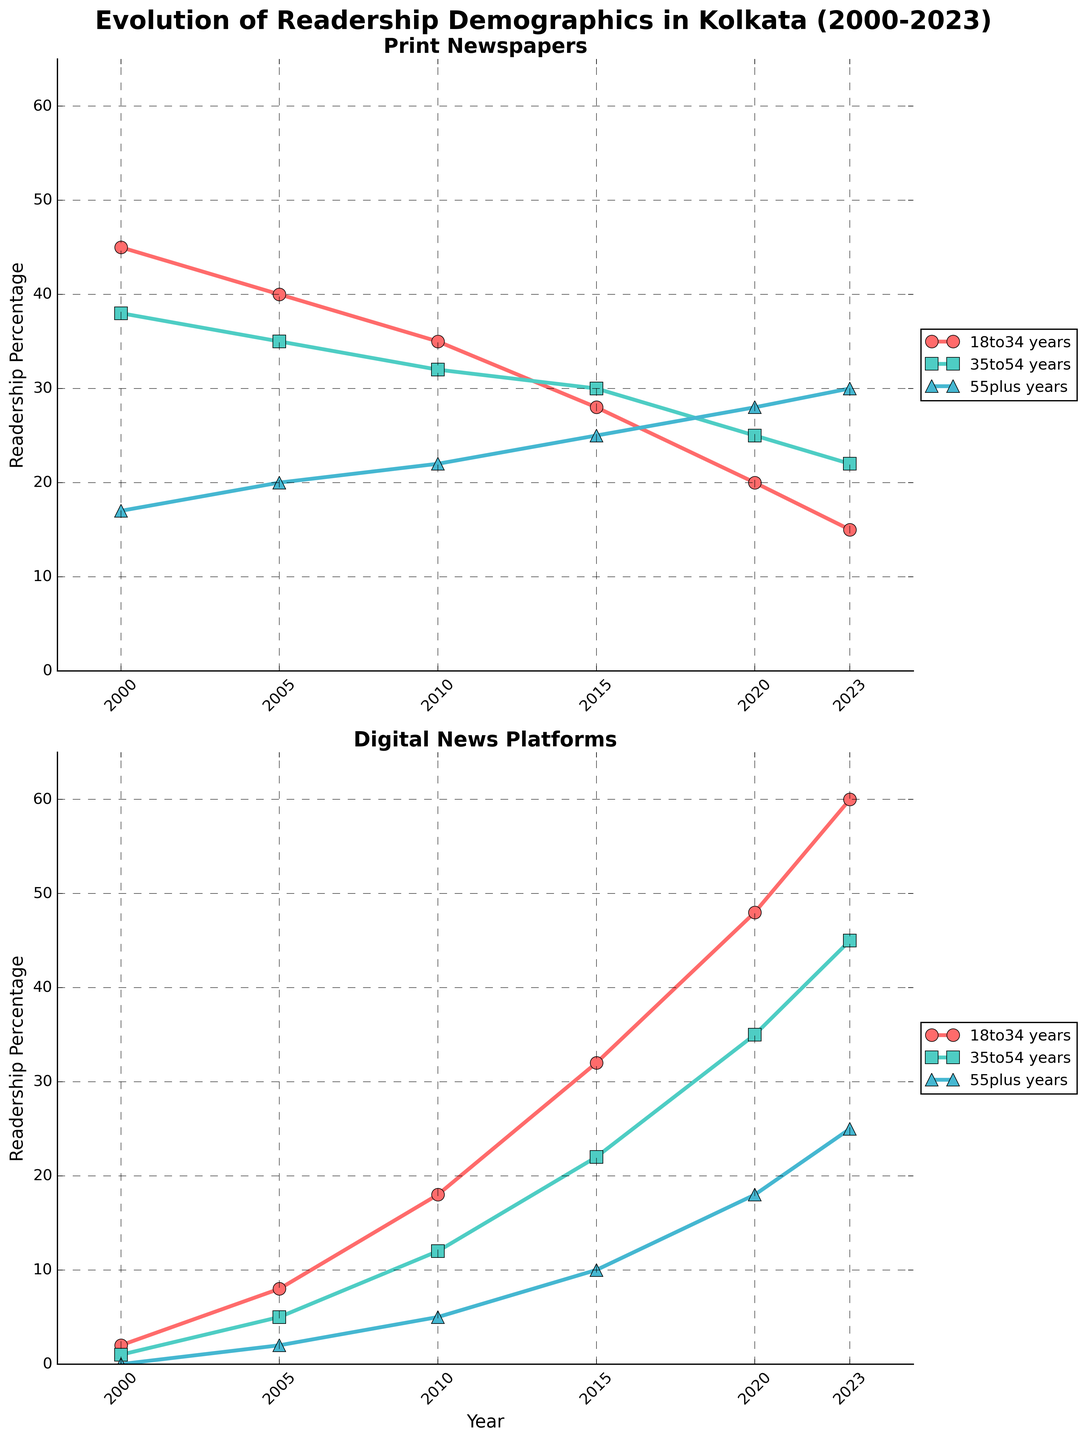What are the titles of the subplots? The titles of the subplots are displayed at the top of each subplot. The first subplot's title is "Print Newspapers" and the second subplot's title is "Digital News Platforms".
Answer: "Print Newspapers" and "Digital News Platforms" How many different age groups are represented in the plots? Each subplot has three lines representing the different age groups. These age groups are 18-34 years, 35-54 years, and 55+ years. Each line corresponds to one of these groups.
Answer: Three Which year shows the highest digital readership for the 55+ age group? Look at the axis labels and plot points for the 55+ age group line in the Digital News Platforms subplot. The highest value is in 2023, where the percentage reaches 25%.
Answer: 2023 By how much did the readership percentage of 18-34 years change for print newspapers from 2000 to 2023? The 18-34 years group for print newspapers starts at 45% in 2000, and it drops to 15% in 2023. The change is calculated as 45% - 15% = 30%.
Answer: 30% What was the readership percentage for the 35-54 age group in digital platforms in 2015? Refer to the 2015 data point for the 35-54 years age group line in the Digital News Platforms subplot. The data point in 2015 shows the readership percentage at 22%.
Answer: 22% In which year did the digital readership percentage of the 18-34 age group first exceed the print readership percentage of the same age group? Observe both subplots and the lines representing the 18-34 age group. In 2010, digital (18%) is still below print (35%). By 2015, digital (32%) exceeds print (28%). Therefore, the year is 2015.
Answer: 2015 What is the difference in readership percentage between print and digital platforms for the 35-54 age group in 2023? In 2023, the 35-54 age group has 22% readership for print and 45% for digital platforms. The difference is calculated as 45% - 22% = 23%.
Answer: 23% How does the trend of the 55+ age group from 2000 to 2023 differ between print and digital platforms? The print platform shows a gradually increasing trend from 17% in 2000 to 30% in 2023. Meanwhile, the digital platform starts at 0% in 2000 and climbs steadily to 25% in 2023.
Answer: Print shows gradual increase; Digital shows rapid increase Between 2000 and 2020, which age group shows the most significant shift towards digital platforms? Compare all age groups in the Digital News Platforms subplot between 2000 and 2020. The 18-34 age group's digital readership starts at 2% in 2000 and rises sharply to 48% in 2020, indicating the most significant shift.
Answer: 18-34 years What is the range of readership percentages for the Print 35-54 group between 2000 and 2023? Check the values for the 35-54 age group line in the Print Newspapers subplot. The minimum value is 22% (2023) and the maximum value is 38% (2000). The range is 38% - 22% = 16%.
Answer: 16% 